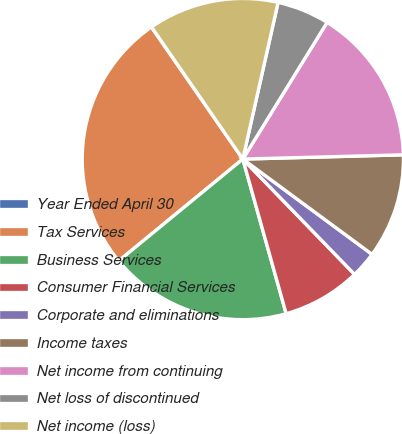Convert chart to OTSL. <chart><loc_0><loc_0><loc_500><loc_500><pie_chart><fcel>Year Ended April 30<fcel>Tax Services<fcel>Business Services<fcel>Consumer Financial Services<fcel>Corporate and eliminations<fcel>Income taxes<fcel>Net income from continuing<fcel>Net loss of discontinued<fcel>Net income (loss)<nl><fcel>0.02%<fcel>26.29%<fcel>18.41%<fcel>7.9%<fcel>2.64%<fcel>10.53%<fcel>15.78%<fcel>5.27%<fcel>13.15%<nl></chart> 